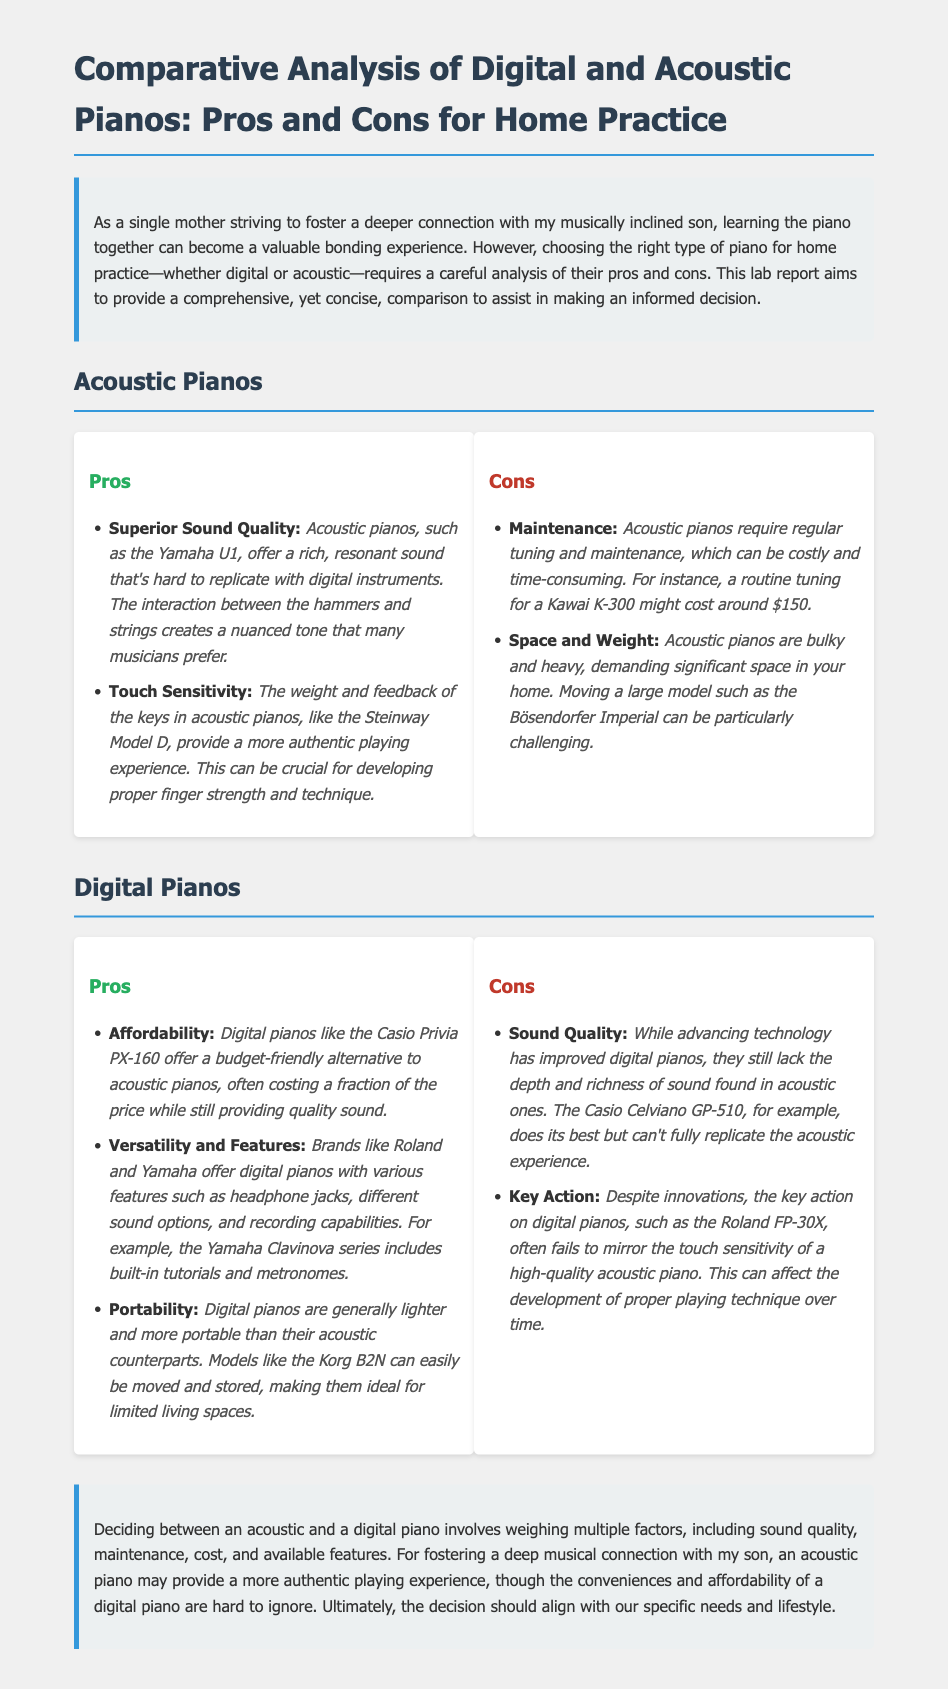What is the primary focus of the report? The report focuses on comparing digital and acoustic pianos, specifically for home practice.
Answer: Comparing digital and acoustic pianos What is one advantage of acoustic pianos mentioned? One advantage is that acoustic pianos offer superior sound quality, providing a rich, resonant sound.
Answer: Superior Sound Quality How much does routine tuning for an acoustic piano typically cost? The document states that a routine tuning for an acoustic piano might cost around $150.
Answer: $150 Which digital piano model is highlighted for its affordability? The Casio Privia PX-160 is mentioned as an affordable digital piano option.
Answer: Casio Privia PX-160 What is a key downside of digital pianos according to the report? The report notes that digital pianos lack the depth and richness of sound found in acoustic pianos.
Answer: Sound Quality How does the report suggest acoustic pianos impact playing technique? It mentions that the touch sensitivity of acoustic pianos can be crucial for developing proper finger strength and technique.
Answer: Proper finger strength and technique What feature is commonly found in digital pianos to enhance practice? Many digital pianos come equipped with built-in tutorials and metronomes to aid in practice.
Answer: Built-in tutorials and metronomes What is the concluding thought regarding the decision between piano types? The conclusion emphasizes that the decision should align with specific needs and lifestyle.
Answer: Specific needs and lifestyle 